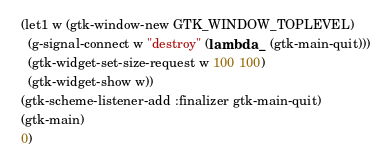Convert code to text. <code><loc_0><loc_0><loc_500><loc_500><_Scheme_>  (let1 w (gtk-window-new GTK_WINDOW_TOPLEVEL)
    (g-signal-connect w "destroy" (lambda _ (gtk-main-quit)))
    (gtk-widget-set-size-request w 100 100)
    (gtk-widget-show w))
  (gtk-scheme-listener-add :finalizer gtk-main-quit)
  (gtk-main)
  0)

</code> 